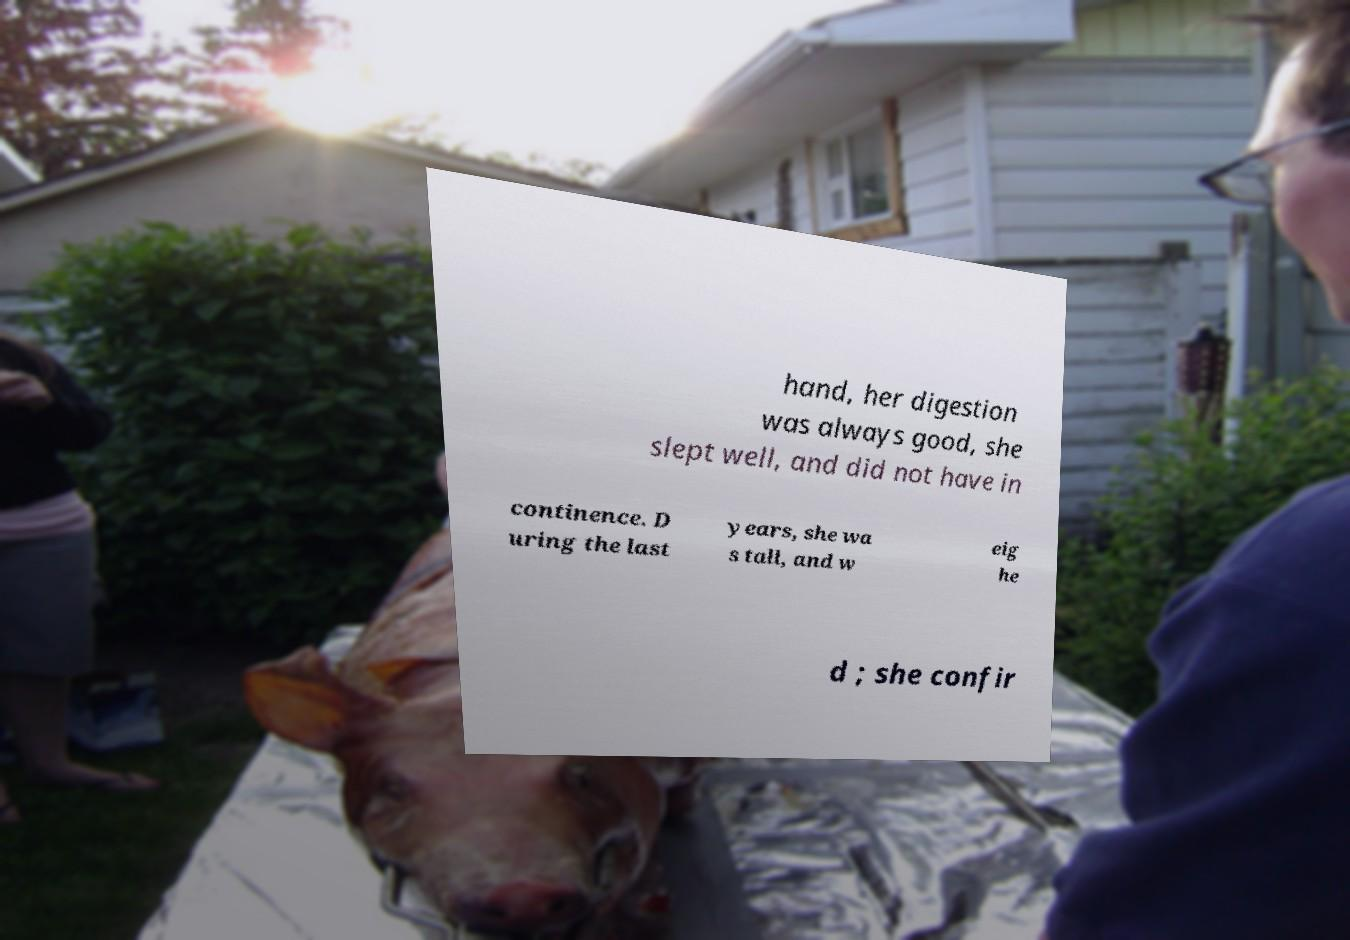There's text embedded in this image that I need extracted. Can you transcribe it verbatim? hand, her digestion was always good, she slept well, and did not have in continence. D uring the last years, she wa s tall, and w eig he d ; she confir 